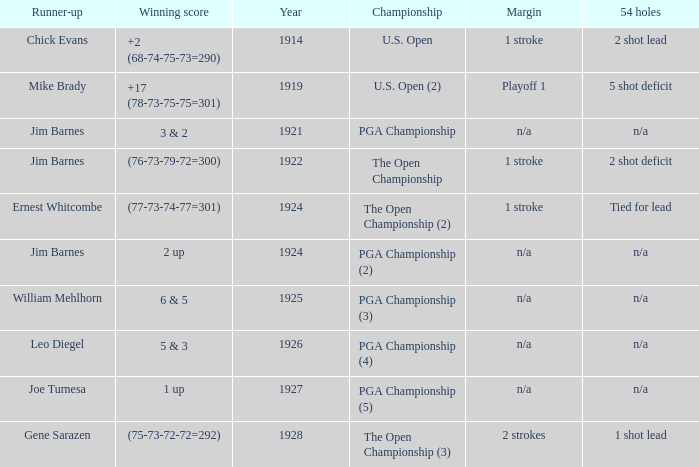Help me parse the entirety of this table. {'header': ['Runner-up', 'Winning score', 'Year', 'Championship', 'Margin', '54 holes'], 'rows': [['Chick Evans', '+2 (68-74-75-73=290)', '1914', 'U.S. Open', '1 stroke', '2 shot lead'], ['Mike Brady', '+17 (78-73-75-75=301)', '1919', 'U.S. Open (2)', 'Playoff 1', '5 shot deficit'], ['Jim Barnes', '3 & 2', '1921', 'PGA Championship', 'n/a', 'n/a'], ['Jim Barnes', '(76-73-79-72=300)', '1922', 'The Open Championship', '1 stroke', '2 shot deficit'], ['Ernest Whitcombe', '(77-73-74-77=301)', '1924', 'The Open Championship (2)', '1 stroke', 'Tied for lead'], ['Jim Barnes', '2 up', '1924', 'PGA Championship (2)', 'n/a', 'n/a'], ['William Mehlhorn', '6 & 5', '1925', 'PGA Championship (3)', 'n/a', 'n/a'], ['Leo Diegel', '5 & 3', '1926', 'PGA Championship (4)', 'n/a', 'n/a'], ['Joe Turnesa', '1 up', '1927', 'PGA Championship (5)', 'n/a', 'n/a'], ['Gene Sarazen', '(75-73-72-72=292)', '1928', 'The Open Championship (3)', '2 strokes', '1 shot lead']]} WHAT YEAR DID MIKE BRADY GET RUNNER-UP? 1919.0. 